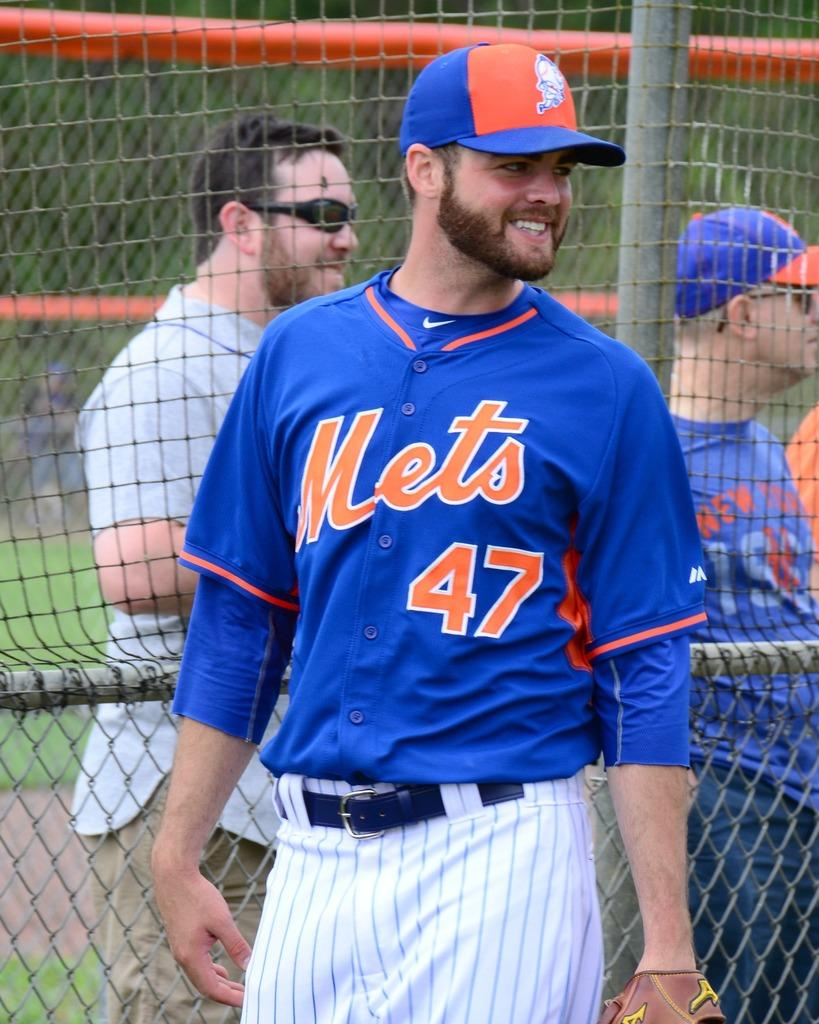<image>
Share a concise interpretation of the image provided. A man in a blue Mets jersey stands and smiles with his head turned. 